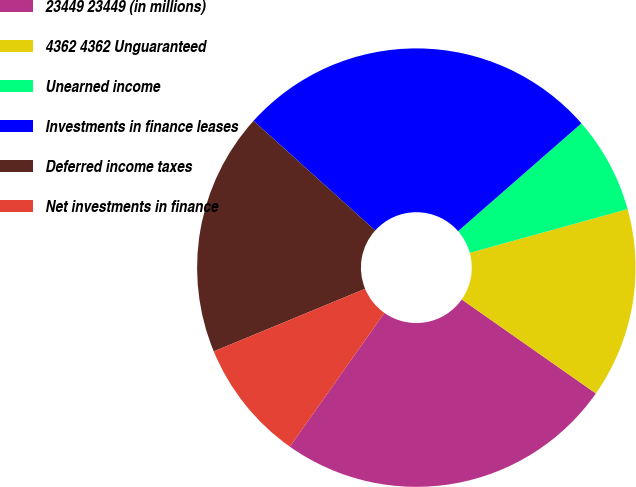Convert chart. <chart><loc_0><loc_0><loc_500><loc_500><pie_chart><fcel>23449 23449 (in millions)<fcel>4362 4362 Unguaranteed<fcel>Unearned income<fcel>Investments in finance leases<fcel>Deferred income taxes<fcel>Net investments in finance<nl><fcel>25.06%<fcel>14.03%<fcel>7.13%<fcel>26.89%<fcel>17.92%<fcel>8.97%<nl></chart> 